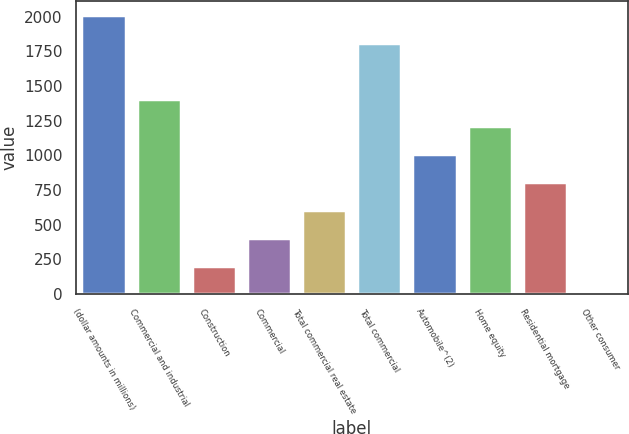Convert chart. <chart><loc_0><loc_0><loc_500><loc_500><bar_chart><fcel>(dollar amounts in millions)<fcel>Commercial and industrial<fcel>Construction<fcel>Commercial<fcel>Total commercial real estate<fcel>Total commercial<fcel>Automobile^(2)<fcel>Home equity<fcel>Residential mortgage<fcel>Other consumer<nl><fcel>2014<fcel>1410.1<fcel>202.3<fcel>403.6<fcel>604.9<fcel>1812.7<fcel>1007.5<fcel>1208.8<fcel>806.2<fcel>1<nl></chart> 